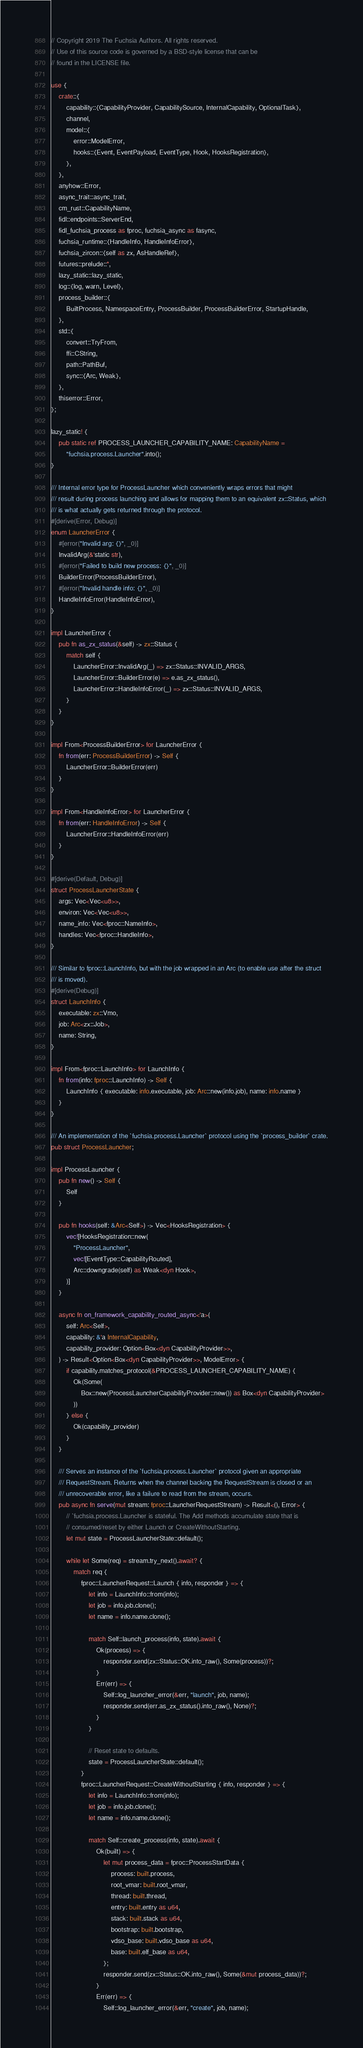Convert code to text. <code><loc_0><loc_0><loc_500><loc_500><_Rust_>// Copyright 2019 The Fuchsia Authors. All rights reserved.
// Use of this source code is governed by a BSD-style license that can be
// found in the LICENSE file.

use {
    crate::{
        capability::{CapabilityProvider, CapabilitySource, InternalCapability, OptionalTask},
        channel,
        model::{
            error::ModelError,
            hooks::{Event, EventPayload, EventType, Hook, HooksRegistration},
        },
    },
    anyhow::Error,
    async_trait::async_trait,
    cm_rust::CapabilityName,
    fidl::endpoints::ServerEnd,
    fidl_fuchsia_process as fproc, fuchsia_async as fasync,
    fuchsia_runtime::{HandleInfo, HandleInfoError},
    fuchsia_zircon::{self as zx, AsHandleRef},
    futures::prelude::*,
    lazy_static::lazy_static,
    log::{log, warn, Level},
    process_builder::{
        BuiltProcess, NamespaceEntry, ProcessBuilder, ProcessBuilderError, StartupHandle,
    },
    std::{
        convert::TryFrom,
        ffi::CString,
        path::PathBuf,
        sync::{Arc, Weak},
    },
    thiserror::Error,
};

lazy_static! {
    pub static ref PROCESS_LAUNCHER_CAPABILITY_NAME: CapabilityName =
        "fuchsia.process.Launcher".into();
}

/// Internal error type for ProcessLauncher which conveniently wraps errors that might
/// result during process launching and allows for mapping them to an equivalent zx::Status, which
/// is what actually gets returned through the protocol.
#[derive(Error, Debug)]
enum LauncherError {
    #[error("Invalid arg: {}", _0)]
    InvalidArg(&'static str),
    #[error("Failed to build new process: {}", _0)]
    BuilderError(ProcessBuilderError),
    #[error("Invalid handle info: {}", _0)]
    HandleInfoError(HandleInfoError),
}

impl LauncherError {
    pub fn as_zx_status(&self) -> zx::Status {
        match self {
            LauncherError::InvalidArg(_) => zx::Status::INVALID_ARGS,
            LauncherError::BuilderError(e) => e.as_zx_status(),
            LauncherError::HandleInfoError(_) => zx::Status::INVALID_ARGS,
        }
    }
}

impl From<ProcessBuilderError> for LauncherError {
    fn from(err: ProcessBuilderError) -> Self {
        LauncherError::BuilderError(err)
    }
}

impl From<HandleInfoError> for LauncherError {
    fn from(err: HandleInfoError) -> Self {
        LauncherError::HandleInfoError(err)
    }
}

#[derive(Default, Debug)]
struct ProcessLauncherState {
    args: Vec<Vec<u8>>,
    environ: Vec<Vec<u8>>,
    name_info: Vec<fproc::NameInfo>,
    handles: Vec<fproc::HandleInfo>,
}

/// Similar to fproc::LaunchInfo, but with the job wrapped in an Arc (to enable use after the struct
/// is moved).
#[derive(Debug)]
struct LaunchInfo {
    executable: zx::Vmo,
    job: Arc<zx::Job>,
    name: String,
}

impl From<fproc::LaunchInfo> for LaunchInfo {
    fn from(info: fproc::LaunchInfo) -> Self {
        LaunchInfo { executable: info.executable, job: Arc::new(info.job), name: info.name }
    }
}

/// An implementation of the `fuchsia.process.Launcher` protocol using the `process_builder` crate.
pub struct ProcessLauncher;

impl ProcessLauncher {
    pub fn new() -> Self {
        Self
    }

    pub fn hooks(self: &Arc<Self>) -> Vec<HooksRegistration> {
        vec![HooksRegistration::new(
            "ProcessLauncher",
            vec![EventType::CapabilityRouted],
            Arc::downgrade(self) as Weak<dyn Hook>,
        )]
    }

    async fn on_framework_capability_routed_async<'a>(
        self: Arc<Self>,
        capability: &'a InternalCapability,
        capability_provider: Option<Box<dyn CapabilityProvider>>,
    ) -> Result<Option<Box<dyn CapabilityProvider>>, ModelError> {
        if capability.matches_protocol(&PROCESS_LAUNCHER_CAPABILITY_NAME) {
            Ok(Some(
                Box::new(ProcessLauncherCapabilityProvider::new()) as Box<dyn CapabilityProvider>
            ))
        } else {
            Ok(capability_provider)
        }
    }

    /// Serves an instance of the `fuchsia.process.Launcher` protocol given an appropriate
    /// RequestStream. Returns when the channel backing the RequestStream is closed or an
    /// unrecoverable error, like a failure to read from the stream, occurs.
    pub async fn serve(mut stream: fproc::LauncherRequestStream) -> Result<(), Error> {
        // `fuchsia.process.Launcher is stateful. The Add methods accumulate state that is
        // consumed/reset by either Launch or CreateWithoutStarting.
        let mut state = ProcessLauncherState::default();

        while let Some(req) = stream.try_next().await? {
            match req {
                fproc::LauncherRequest::Launch { info, responder } => {
                    let info = LaunchInfo::from(info);
                    let job = info.job.clone();
                    let name = info.name.clone();

                    match Self::launch_process(info, state).await {
                        Ok(process) => {
                            responder.send(zx::Status::OK.into_raw(), Some(process))?;
                        }
                        Err(err) => {
                            Self::log_launcher_error(&err, "launch", job, name);
                            responder.send(err.as_zx_status().into_raw(), None)?;
                        }
                    }

                    // Reset state to defaults.
                    state = ProcessLauncherState::default();
                }
                fproc::LauncherRequest::CreateWithoutStarting { info, responder } => {
                    let info = LaunchInfo::from(info);
                    let job = info.job.clone();
                    let name = info.name.clone();

                    match Self::create_process(info, state).await {
                        Ok(built) => {
                            let mut process_data = fproc::ProcessStartData {
                                process: built.process,
                                root_vmar: built.root_vmar,
                                thread: built.thread,
                                entry: built.entry as u64,
                                stack: built.stack as u64,
                                bootstrap: built.bootstrap,
                                vdso_base: built.vdso_base as u64,
                                base: built.elf_base as u64,
                            };
                            responder.send(zx::Status::OK.into_raw(), Some(&mut process_data))?;
                        }
                        Err(err) => {
                            Self::log_launcher_error(&err, "create", job, name);</code> 